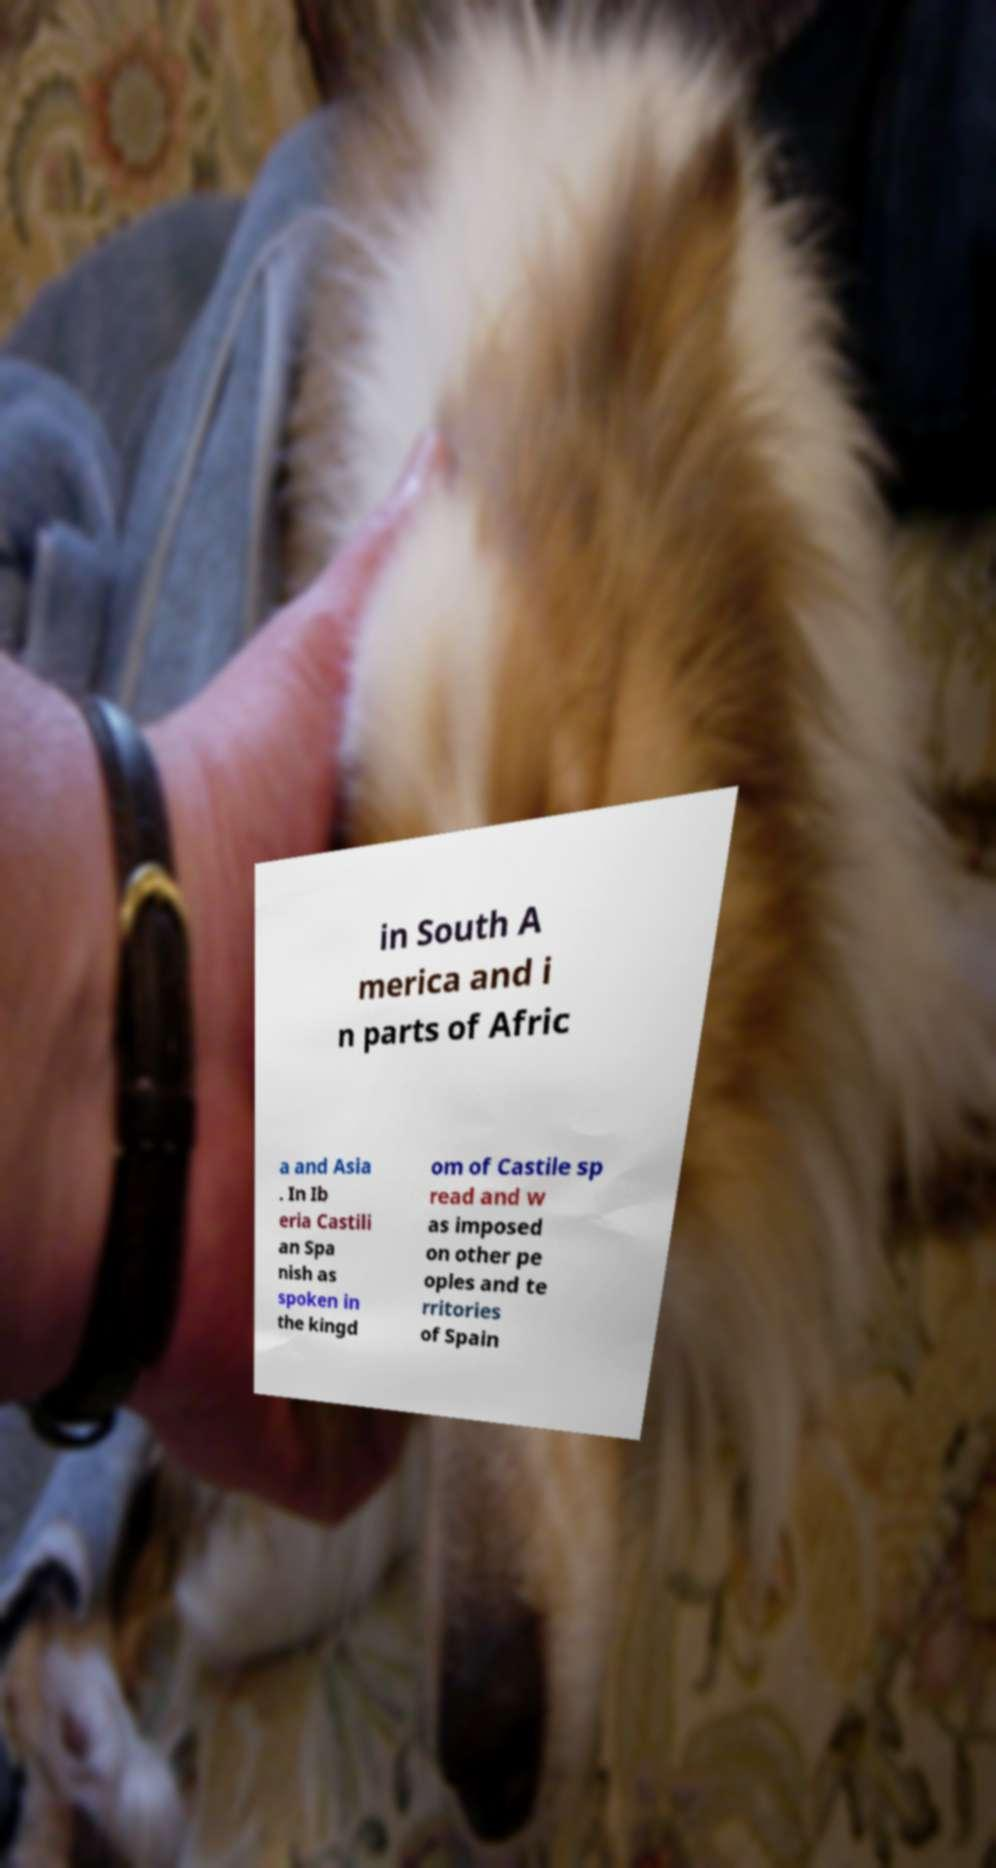Can you read and provide the text displayed in the image?This photo seems to have some interesting text. Can you extract and type it out for me? in South A merica and i n parts of Afric a and Asia . In Ib eria Castili an Spa nish as spoken in the kingd om of Castile sp read and w as imposed on other pe oples and te rritories of Spain 